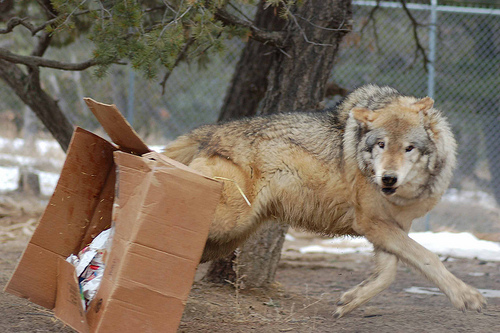<image>
Is there a dog under the box? No. The dog is not positioned under the box. The vertical relationship between these objects is different. 